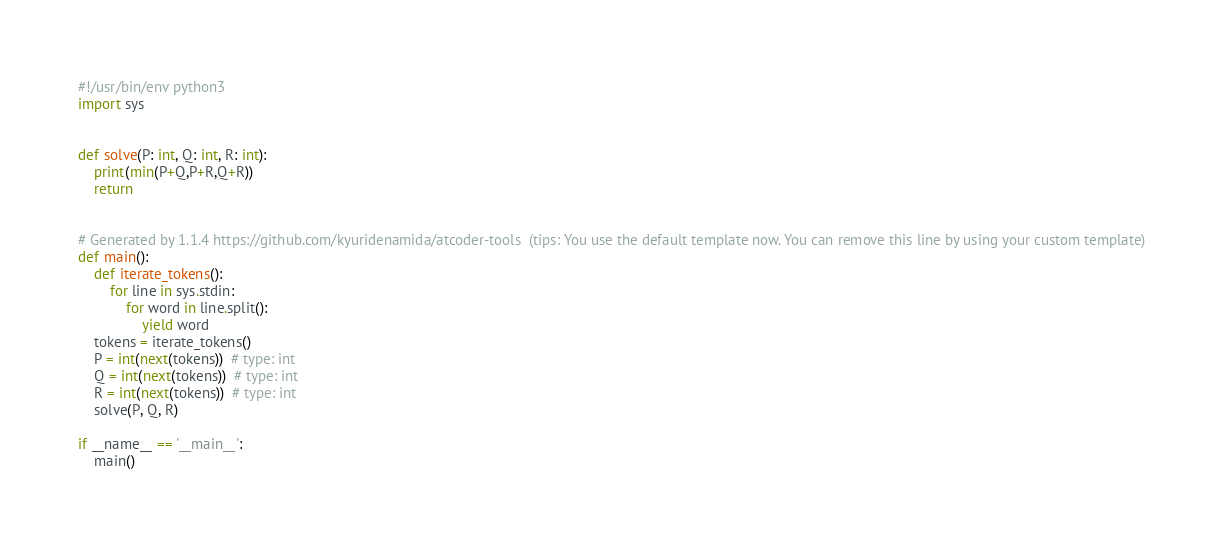Convert code to text. <code><loc_0><loc_0><loc_500><loc_500><_Python_>#!/usr/bin/env python3
import sys


def solve(P: int, Q: int, R: int):
    print(min(P+Q,P+R,Q+R))
    return


# Generated by 1.1.4 https://github.com/kyuridenamida/atcoder-tools  (tips: You use the default template now. You can remove this line by using your custom template)
def main():
    def iterate_tokens():
        for line in sys.stdin:
            for word in line.split():
                yield word
    tokens = iterate_tokens()
    P = int(next(tokens))  # type: int
    Q = int(next(tokens))  # type: int
    R = int(next(tokens))  # type: int
    solve(P, Q, R)

if __name__ == '__main__':
    main()
</code> 